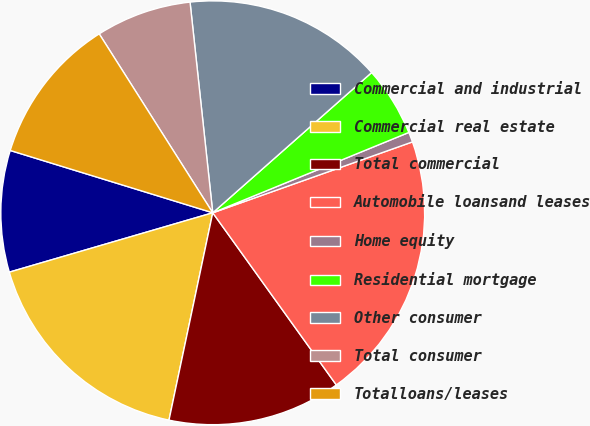Convert chart. <chart><loc_0><loc_0><loc_500><loc_500><pie_chart><fcel>Commercial and industrial<fcel>Commercial real estate<fcel>Total commercial<fcel>Automobile loansand leases<fcel>Home equity<fcel>Residential mortgage<fcel>Other consumer<fcel>Total consumer<fcel>Totalloans/leases<nl><fcel>9.27%<fcel>17.17%<fcel>13.22%<fcel>20.52%<fcel>0.76%<fcel>5.32%<fcel>15.2%<fcel>7.29%<fcel>11.25%<nl></chart> 